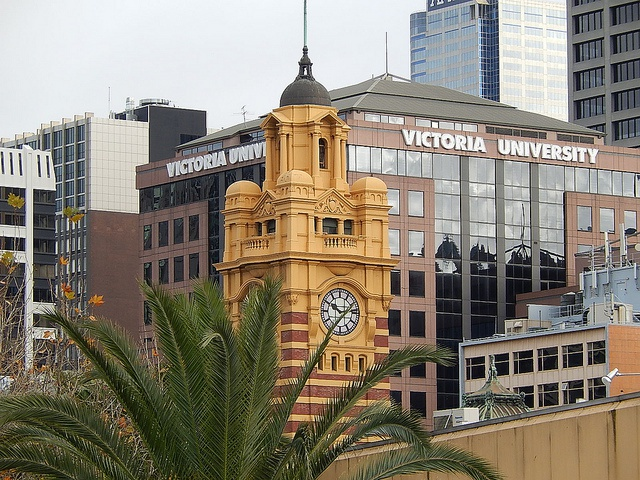Describe the objects in this image and their specific colors. I can see a clock in lightgray, black, gray, and darkgray tones in this image. 